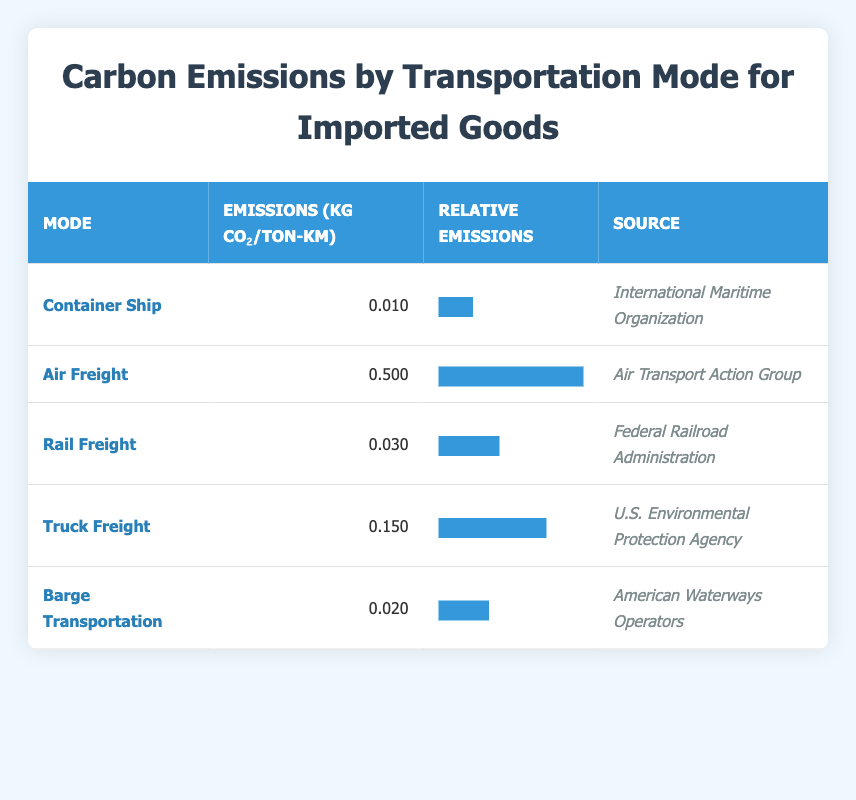What is the emission value for Air Freight? The table directly provides the emissions value listed for Air Freight under the "Emissions (kg CO₂/ton-km)" column, which states that it emits 0.500.
Answer: 0.500 Which transportation mode has the lowest carbon emissions? The table displays the emissions values for all modes. Container Ship has the lowest emissions at 0.010 kg CO₂/ton-km, making it the mode with the least impact.
Answer: Container Ship What is the difference in emissions between Truck Freight and Rail Freight? The emissions for Truck Freight is 0.150 kg CO₂/ton-km, while Rail Freight is at 0.030 kg CO₂/ton-km. The difference is 0.150 - 0.030 = 0.120 kg CO₂/ton-km.
Answer: 0.120 Is the carbon emissions for Barge Transportation greater than that of Container Ship? Barge Transportation has emissions of 0.020 kg CO₂/ton-km and Container Ship has emissions of 0.010 kg CO₂/ton-km. Since 0.020 is greater than 0.010, the statement is true.
Answer: Yes Which modes of transportation have emissions below 0.050 kg CO₂/ton-km? Looking at the emissions values, both Container Ship (0.010) and Barge Transportation (0.020) are below 0.050 kg CO₂/ton-km. Therefore, they meet the criteria.
Answer: Container Ship, Barge Transportation What is the average carbon emission value of all listed transportation modes? The emissions are summed up: 0.010 + 0.500 + 0.030 + 0.150 + 0.020 = 0.710 kg CO₂/ton-km. There are 5 modes, so the average is 0.710 / 5 = 0.142 kg CO₂/ton-km.
Answer: 0.142 Which mode has emissions that is at least five times lower than Air Freight? Air Freight’s emissions are 0.500. Five times lower would be 0.500 / 5 = 0.100. Both Container Ship (0.010) and Barge Transportation (0.020) are below this threshold, thus they qualify.
Answer: Container Ship, Barge Transportation Compare the relative emissions of Rail Freight and Truck Freight. Rail Freight has 0.030 emissions compared to Truck Freight’s 0.150. Truck Freight has higher relative emissions, as 0.150 is larger than 0.030 which shows it emits more carbon dioxide per ton-km than Rail Freight.
Answer: Truck Freight has higher emissions 